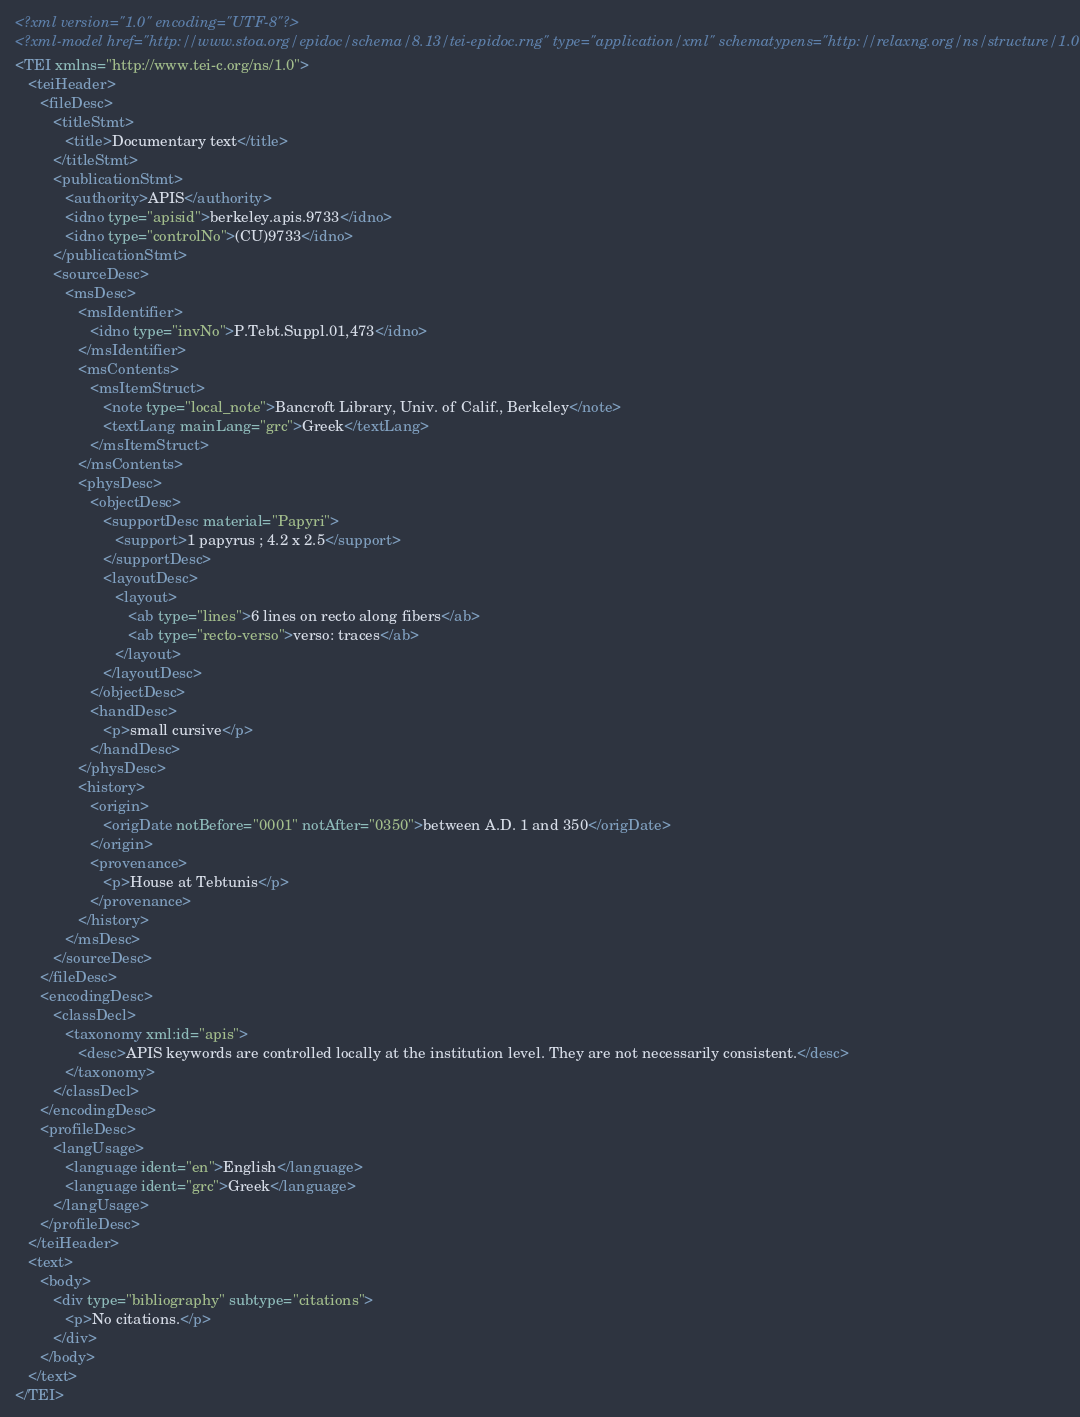Convert code to text. <code><loc_0><loc_0><loc_500><loc_500><_XML_><?xml version="1.0" encoding="UTF-8"?>
<?xml-model href="http://www.stoa.org/epidoc/schema/8.13/tei-epidoc.rng" type="application/xml" schematypens="http://relaxng.org/ns/structure/1.0"?>
<TEI xmlns="http://www.tei-c.org/ns/1.0">
   <teiHeader>
      <fileDesc>
         <titleStmt>
            <title>Documentary text</title>
         </titleStmt>
         <publicationStmt>
            <authority>APIS</authority>
            <idno type="apisid">berkeley.apis.9733</idno>
            <idno type="controlNo">(CU)9733</idno>
         </publicationStmt>
         <sourceDesc>
            <msDesc>
               <msIdentifier>
                  <idno type="invNo">P.Tebt.Suppl.01,473</idno>
               </msIdentifier>
               <msContents>
                  <msItemStruct>
                     <note type="local_note">Bancroft Library, Univ. of Calif., Berkeley</note>
                     <textLang mainLang="grc">Greek</textLang>
                  </msItemStruct>
               </msContents>
               <physDesc>
                  <objectDesc>
                     <supportDesc material="Papyri">
                        <support>1 papyrus ; 4.2 x 2.5</support>
                     </supportDesc>
                     <layoutDesc>
                        <layout>
                           <ab type="lines">6 lines on recto along fibers</ab>
                           <ab type="recto-verso">verso: traces</ab>
                        </layout>
                     </layoutDesc>
                  </objectDesc>
                  <handDesc>
                     <p>small cursive</p>
                  </handDesc>
               </physDesc>
               <history>
                  <origin>
                     <origDate notBefore="0001" notAfter="0350">between A.D. 1 and 350</origDate>
                  </origin>
                  <provenance>
                     <p>House at Tebtunis</p>
                  </provenance>
               </history>
            </msDesc>
         </sourceDesc>
      </fileDesc>
      <encodingDesc>
         <classDecl>
            <taxonomy xml:id="apis">
               <desc>APIS keywords are controlled locally at the institution level. They are not necessarily consistent.</desc>
            </taxonomy>
         </classDecl>
      </encodingDesc>
      <profileDesc>
         <langUsage>
            <language ident="en">English</language>
            <language ident="grc">Greek</language>
         </langUsage>
      </profileDesc>
   </teiHeader>
   <text>
      <body>
         <div type="bibliography" subtype="citations">
            <p>No citations.</p>
         </div>
      </body>
   </text>
</TEI></code> 